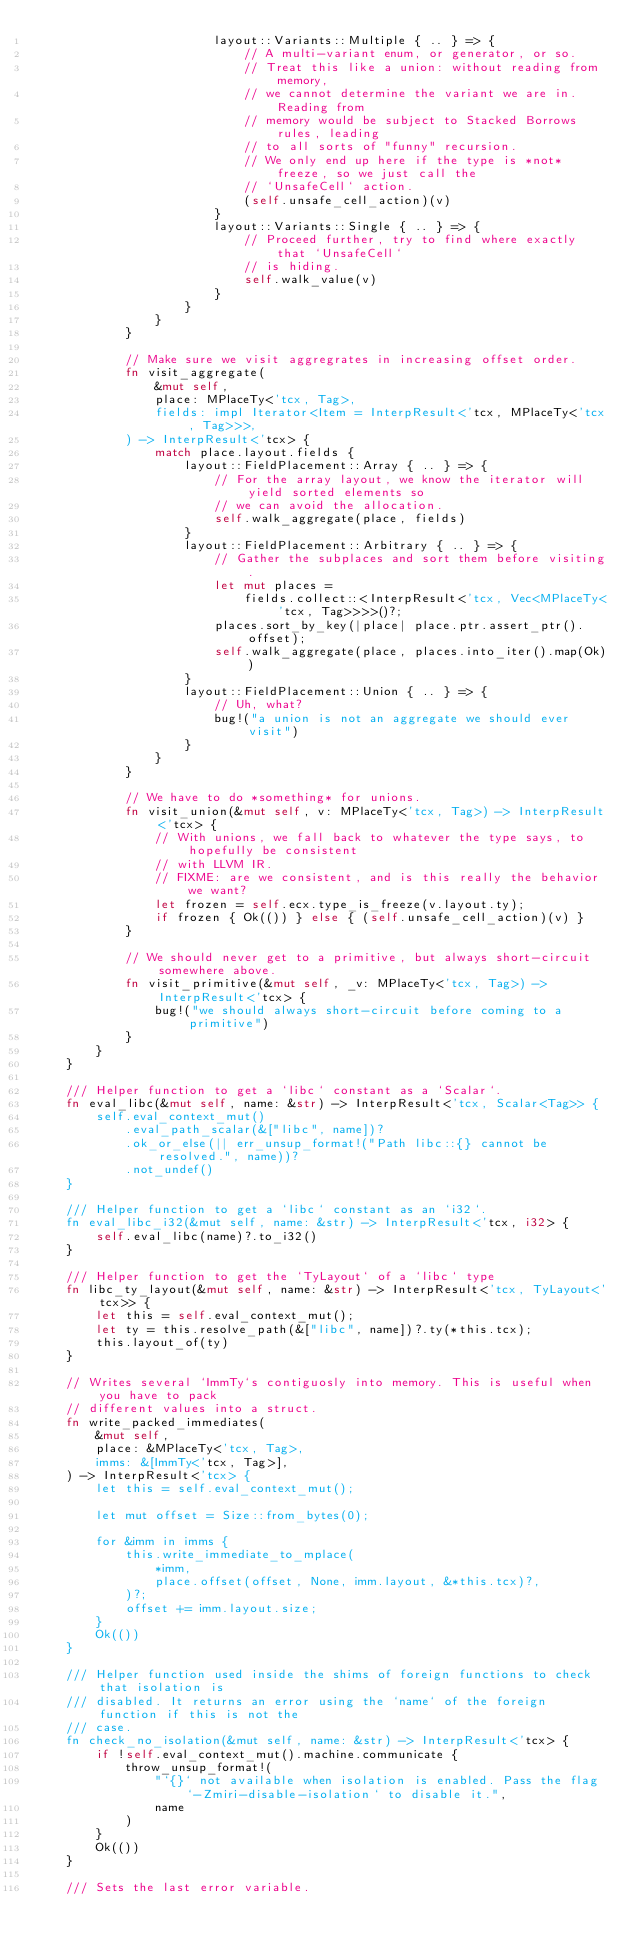<code> <loc_0><loc_0><loc_500><loc_500><_Rust_>                        layout::Variants::Multiple { .. } => {
                            // A multi-variant enum, or generator, or so.
                            // Treat this like a union: without reading from memory,
                            // we cannot determine the variant we are in. Reading from
                            // memory would be subject to Stacked Borrows rules, leading
                            // to all sorts of "funny" recursion.
                            // We only end up here if the type is *not* freeze, so we just call the
                            // `UnsafeCell` action.
                            (self.unsafe_cell_action)(v)
                        }
                        layout::Variants::Single { .. } => {
                            // Proceed further, try to find where exactly that `UnsafeCell`
                            // is hiding.
                            self.walk_value(v)
                        }
                    }
                }
            }

            // Make sure we visit aggregrates in increasing offset order.
            fn visit_aggregate(
                &mut self,
                place: MPlaceTy<'tcx, Tag>,
                fields: impl Iterator<Item = InterpResult<'tcx, MPlaceTy<'tcx, Tag>>>,
            ) -> InterpResult<'tcx> {
                match place.layout.fields {
                    layout::FieldPlacement::Array { .. } => {
                        // For the array layout, we know the iterator will yield sorted elements so
                        // we can avoid the allocation.
                        self.walk_aggregate(place, fields)
                    }
                    layout::FieldPlacement::Arbitrary { .. } => {
                        // Gather the subplaces and sort them before visiting.
                        let mut places =
                            fields.collect::<InterpResult<'tcx, Vec<MPlaceTy<'tcx, Tag>>>>()?;
                        places.sort_by_key(|place| place.ptr.assert_ptr().offset);
                        self.walk_aggregate(place, places.into_iter().map(Ok))
                    }
                    layout::FieldPlacement::Union { .. } => {
                        // Uh, what?
                        bug!("a union is not an aggregate we should ever visit")
                    }
                }
            }

            // We have to do *something* for unions.
            fn visit_union(&mut self, v: MPlaceTy<'tcx, Tag>) -> InterpResult<'tcx> {
                // With unions, we fall back to whatever the type says, to hopefully be consistent
                // with LLVM IR.
                // FIXME: are we consistent, and is this really the behavior we want?
                let frozen = self.ecx.type_is_freeze(v.layout.ty);
                if frozen { Ok(()) } else { (self.unsafe_cell_action)(v) }
            }

            // We should never get to a primitive, but always short-circuit somewhere above.
            fn visit_primitive(&mut self, _v: MPlaceTy<'tcx, Tag>) -> InterpResult<'tcx> {
                bug!("we should always short-circuit before coming to a primitive")
            }
        }
    }

    /// Helper function to get a `libc` constant as a `Scalar`.
    fn eval_libc(&mut self, name: &str) -> InterpResult<'tcx, Scalar<Tag>> {
        self.eval_context_mut()
            .eval_path_scalar(&["libc", name])?
            .ok_or_else(|| err_unsup_format!("Path libc::{} cannot be resolved.", name))?
            .not_undef()
    }

    /// Helper function to get a `libc` constant as an `i32`.
    fn eval_libc_i32(&mut self, name: &str) -> InterpResult<'tcx, i32> {
        self.eval_libc(name)?.to_i32()
    }

    /// Helper function to get the `TyLayout` of a `libc` type
    fn libc_ty_layout(&mut self, name: &str) -> InterpResult<'tcx, TyLayout<'tcx>> {
        let this = self.eval_context_mut();
        let ty = this.resolve_path(&["libc", name])?.ty(*this.tcx);
        this.layout_of(ty)
    }

    // Writes several `ImmTy`s contiguosly into memory. This is useful when you have to pack
    // different values into a struct.
    fn write_packed_immediates(
        &mut self,
        place: &MPlaceTy<'tcx, Tag>,
        imms: &[ImmTy<'tcx, Tag>],
    ) -> InterpResult<'tcx> {
        let this = self.eval_context_mut();

        let mut offset = Size::from_bytes(0);

        for &imm in imms {
            this.write_immediate_to_mplace(
                *imm,
                place.offset(offset, None, imm.layout, &*this.tcx)?,
            )?;
            offset += imm.layout.size;
        }
        Ok(())
    }

    /// Helper function used inside the shims of foreign functions to check that isolation is
    /// disabled. It returns an error using the `name` of the foreign function if this is not the
    /// case.
    fn check_no_isolation(&mut self, name: &str) -> InterpResult<'tcx> {
        if !self.eval_context_mut().machine.communicate {
            throw_unsup_format!(
                "`{}` not available when isolation is enabled. Pass the flag `-Zmiri-disable-isolation` to disable it.",
                name
            )
        }
        Ok(())
    }

    /// Sets the last error variable.</code> 